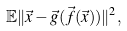Convert formula to latex. <formula><loc_0><loc_0><loc_500><loc_500>\mathbb { E } \| \vec { x } - \vec { g } ( \vec { f } ( \vec { x } ) ) \| ^ { 2 } ,</formula> 